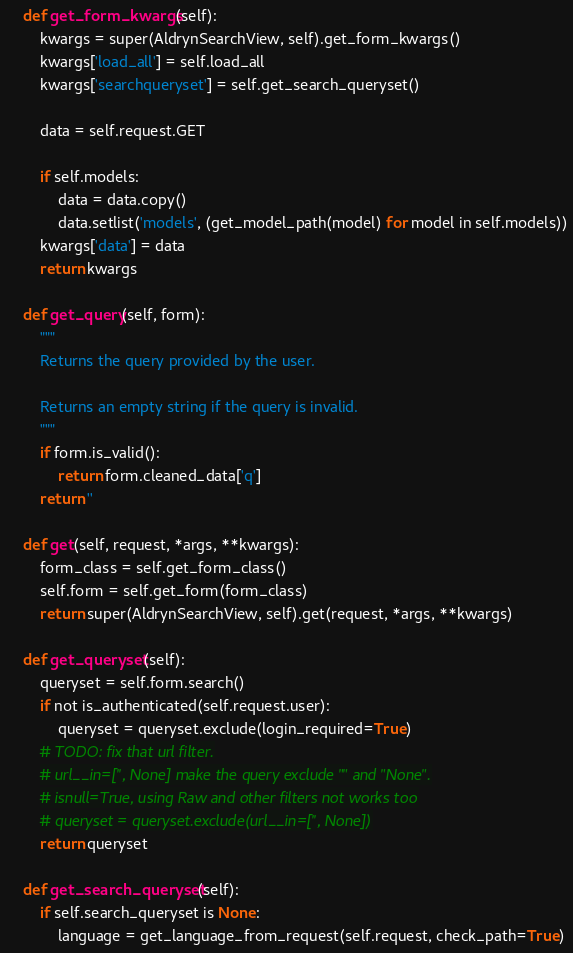Convert code to text. <code><loc_0><loc_0><loc_500><loc_500><_Python_>    def get_form_kwargs(self):
        kwargs = super(AldrynSearchView, self).get_form_kwargs()
        kwargs['load_all'] = self.load_all
        kwargs['searchqueryset'] = self.get_search_queryset()

        data = self.request.GET

        if self.models:
            data = data.copy()
            data.setlist('models', (get_model_path(model) for model in self.models))
        kwargs['data'] = data
        return kwargs

    def get_query(self, form):
        """
        Returns the query provided by the user.

        Returns an empty string if the query is invalid.
        """
        if form.is_valid():
            return form.cleaned_data['q']
        return ''

    def get(self, request, *args, **kwargs):
        form_class = self.get_form_class()
        self.form = self.get_form(form_class)
        return super(AldrynSearchView, self).get(request, *args, **kwargs)

    def get_queryset(self):
        queryset = self.form.search()
        if not is_authenticated(self.request.user):
            queryset = queryset.exclude(login_required=True)
        # TODO: fix that url filter.
        # url__in=['', None] make the query exclude "" and "None".
        # isnull=True, using Raw and other filters not works too
        # queryset = queryset.exclude(url__in=['', None])
        return queryset

    def get_search_queryset(self):
        if self.search_queryset is None:
            language = get_language_from_request(self.request, check_path=True)</code> 